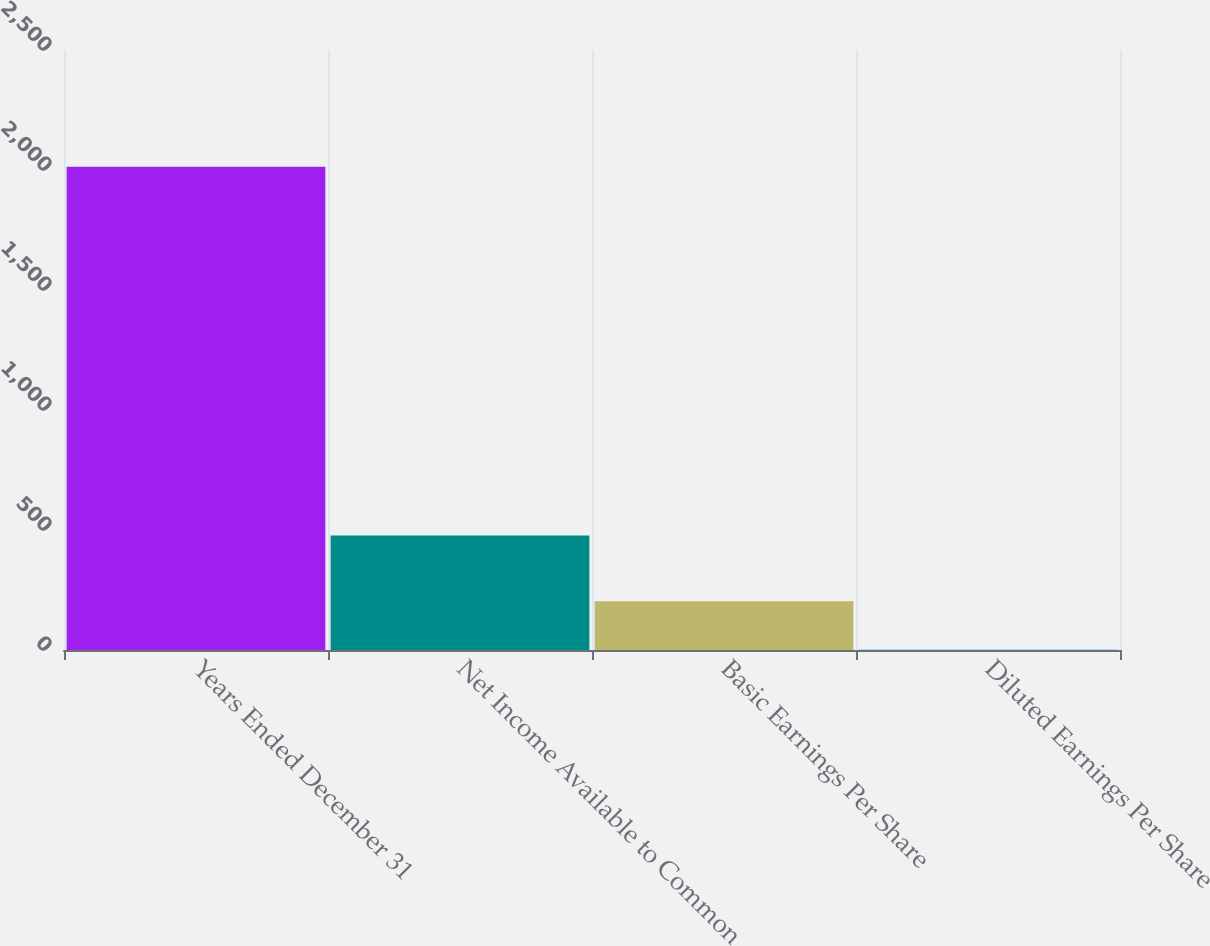Convert chart to OTSL. <chart><loc_0><loc_0><loc_500><loc_500><bar_chart><fcel>Years Ended December 31<fcel>Net Income Available to Common<fcel>Basic Earnings Per Share<fcel>Diluted Earnings Per Share<nl><fcel>2014<fcel>477<fcel>202.97<fcel>1.74<nl></chart> 